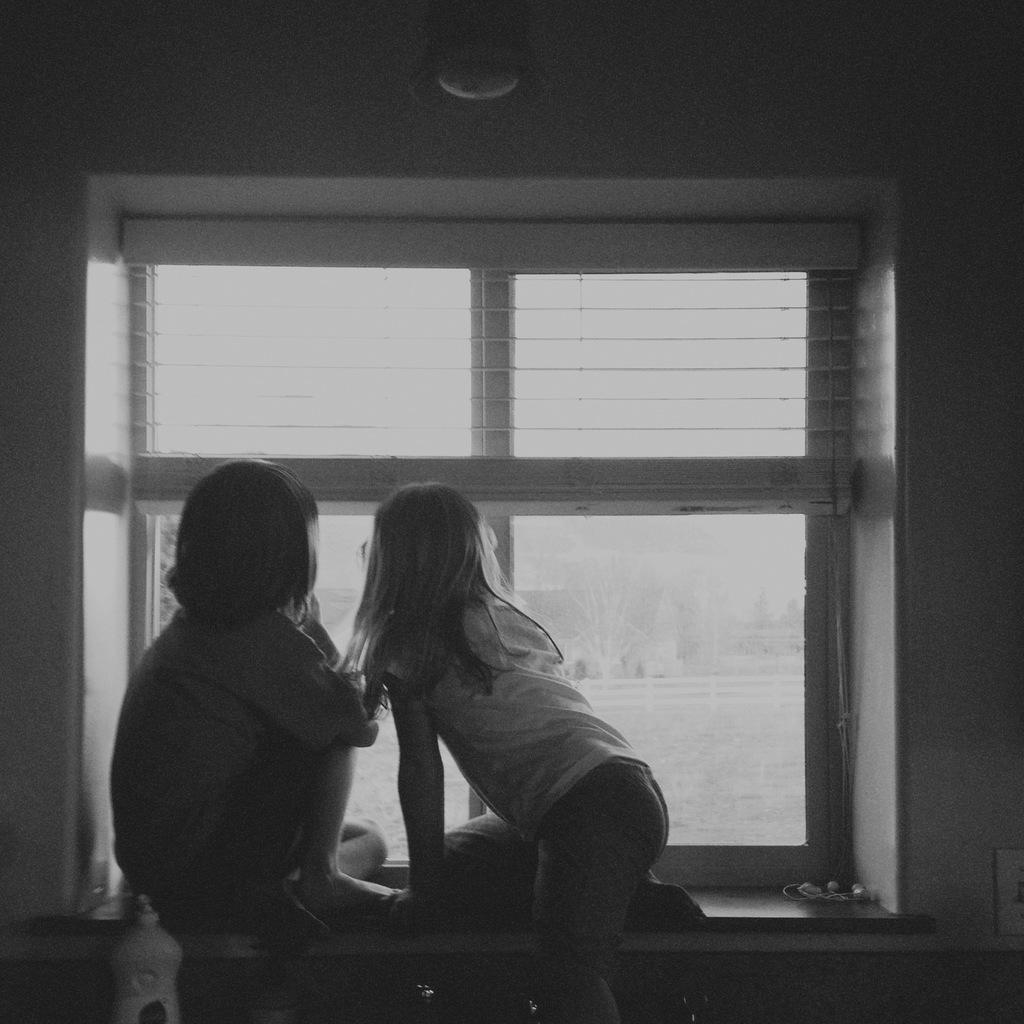What is the color scheme of the image? The image is black and white. How many kids are present in the room? There are two kids in the room. Where are the kids located in the room? The kids are sitting near a window. What are the kids doing in the image? The kids are peeking out through the glass panes of the window. What can be seen outside the window? There are trees visible through the window. What type of clouds can be seen in the image? There are no clouds visible in the image, as it is a black and white picture of two kids sitting near a window. What kind of art is displayed on the walls in the image? There is no mention of any art displayed on the walls in the provided facts, so we cannot answer that question. 